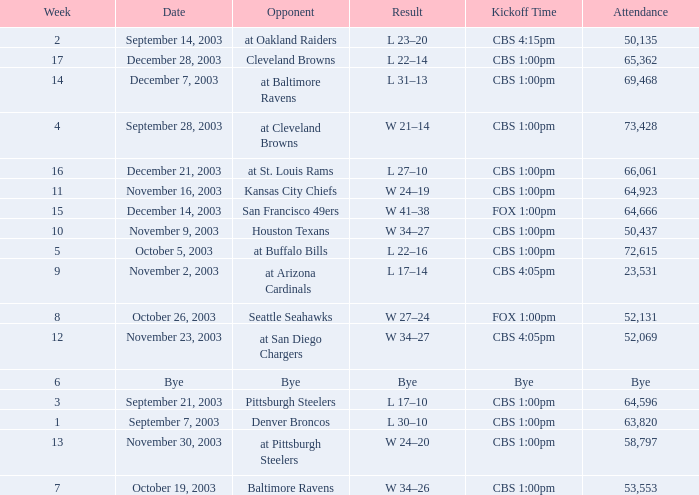What is the average number of weeks that the opponent was the Denver Broncos? 1.0. 